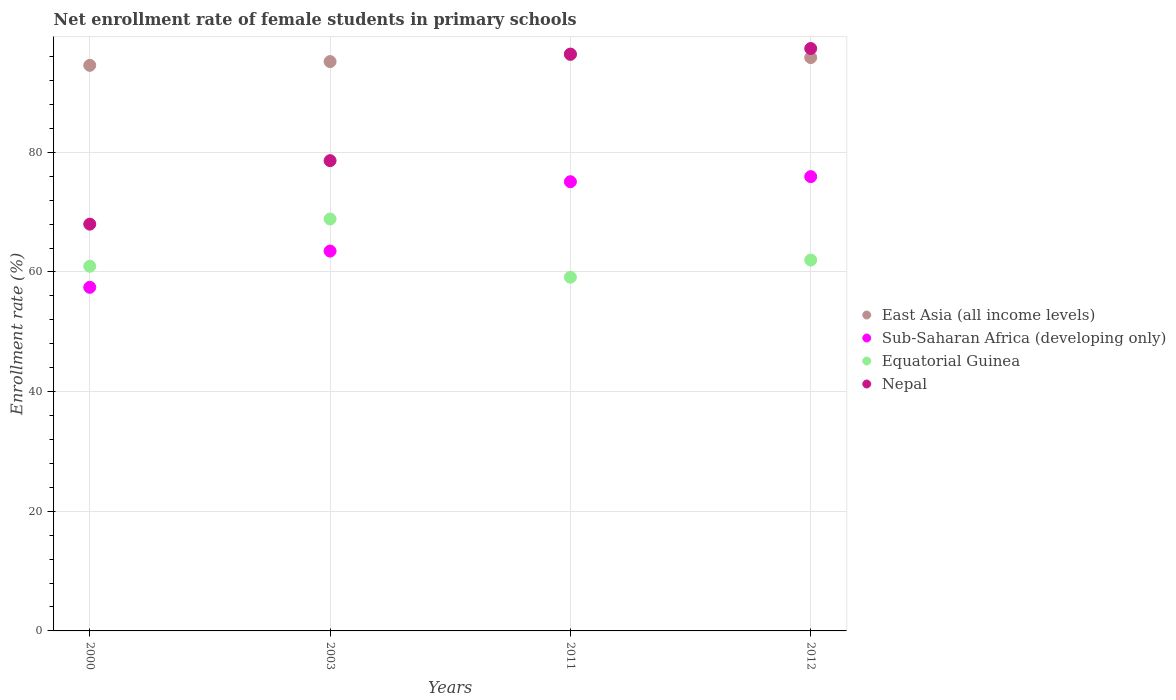Is the number of dotlines equal to the number of legend labels?
Keep it short and to the point. Yes. What is the net enrollment rate of female students in primary schools in East Asia (all income levels) in 2012?
Ensure brevity in your answer.  95.83. Across all years, what is the maximum net enrollment rate of female students in primary schools in East Asia (all income levels)?
Your answer should be compact. 96.33. Across all years, what is the minimum net enrollment rate of female students in primary schools in Equatorial Guinea?
Offer a very short reply. 59.13. In which year was the net enrollment rate of female students in primary schools in Sub-Saharan Africa (developing only) maximum?
Ensure brevity in your answer.  2012. What is the total net enrollment rate of female students in primary schools in East Asia (all income levels) in the graph?
Make the answer very short. 381.87. What is the difference between the net enrollment rate of female students in primary schools in East Asia (all income levels) in 2011 and that in 2012?
Offer a terse response. 0.49. What is the difference between the net enrollment rate of female students in primary schools in Sub-Saharan Africa (developing only) in 2011 and the net enrollment rate of female students in primary schools in Equatorial Guinea in 2000?
Offer a very short reply. 14.13. What is the average net enrollment rate of female students in primary schools in East Asia (all income levels) per year?
Give a very brief answer. 95.47. In the year 2012, what is the difference between the net enrollment rate of female students in primary schools in Equatorial Guinea and net enrollment rate of female students in primary schools in Sub-Saharan Africa (developing only)?
Give a very brief answer. -13.95. What is the ratio of the net enrollment rate of female students in primary schools in East Asia (all income levels) in 2000 to that in 2003?
Keep it short and to the point. 0.99. Is the net enrollment rate of female students in primary schools in Equatorial Guinea in 2003 less than that in 2012?
Keep it short and to the point. No. Is the difference between the net enrollment rate of female students in primary schools in Equatorial Guinea in 2000 and 2003 greater than the difference between the net enrollment rate of female students in primary schools in Sub-Saharan Africa (developing only) in 2000 and 2003?
Ensure brevity in your answer.  No. What is the difference between the highest and the second highest net enrollment rate of female students in primary schools in Equatorial Guinea?
Provide a short and direct response. 6.86. What is the difference between the highest and the lowest net enrollment rate of female students in primary schools in East Asia (all income levels)?
Ensure brevity in your answer.  1.79. Is the sum of the net enrollment rate of female students in primary schools in Equatorial Guinea in 2011 and 2012 greater than the maximum net enrollment rate of female students in primary schools in Sub-Saharan Africa (developing only) across all years?
Offer a very short reply. Yes. Is the net enrollment rate of female students in primary schools in Nepal strictly less than the net enrollment rate of female students in primary schools in East Asia (all income levels) over the years?
Keep it short and to the point. No. How many years are there in the graph?
Provide a short and direct response. 4. How many legend labels are there?
Your response must be concise. 4. What is the title of the graph?
Make the answer very short. Net enrollment rate of female students in primary schools. What is the label or title of the Y-axis?
Your answer should be very brief. Enrollment rate (%). What is the Enrollment rate (%) of East Asia (all income levels) in 2000?
Ensure brevity in your answer.  94.54. What is the Enrollment rate (%) of Sub-Saharan Africa (developing only) in 2000?
Make the answer very short. 57.43. What is the Enrollment rate (%) in Equatorial Guinea in 2000?
Your answer should be very brief. 60.96. What is the Enrollment rate (%) in Nepal in 2000?
Give a very brief answer. 67.99. What is the Enrollment rate (%) of East Asia (all income levels) in 2003?
Provide a short and direct response. 95.17. What is the Enrollment rate (%) in Sub-Saharan Africa (developing only) in 2003?
Make the answer very short. 63.49. What is the Enrollment rate (%) of Equatorial Guinea in 2003?
Give a very brief answer. 68.85. What is the Enrollment rate (%) in Nepal in 2003?
Provide a succinct answer. 78.61. What is the Enrollment rate (%) of East Asia (all income levels) in 2011?
Your response must be concise. 96.33. What is the Enrollment rate (%) of Sub-Saharan Africa (developing only) in 2011?
Your answer should be compact. 75.09. What is the Enrollment rate (%) of Equatorial Guinea in 2011?
Offer a very short reply. 59.13. What is the Enrollment rate (%) in Nepal in 2011?
Your answer should be very brief. 96.42. What is the Enrollment rate (%) in East Asia (all income levels) in 2012?
Offer a very short reply. 95.83. What is the Enrollment rate (%) in Sub-Saharan Africa (developing only) in 2012?
Make the answer very short. 75.94. What is the Enrollment rate (%) in Equatorial Guinea in 2012?
Offer a very short reply. 61.99. What is the Enrollment rate (%) of Nepal in 2012?
Make the answer very short. 97.35. Across all years, what is the maximum Enrollment rate (%) in East Asia (all income levels)?
Offer a terse response. 96.33. Across all years, what is the maximum Enrollment rate (%) of Sub-Saharan Africa (developing only)?
Offer a very short reply. 75.94. Across all years, what is the maximum Enrollment rate (%) of Equatorial Guinea?
Offer a very short reply. 68.85. Across all years, what is the maximum Enrollment rate (%) of Nepal?
Offer a terse response. 97.35. Across all years, what is the minimum Enrollment rate (%) of East Asia (all income levels)?
Ensure brevity in your answer.  94.54. Across all years, what is the minimum Enrollment rate (%) in Sub-Saharan Africa (developing only)?
Ensure brevity in your answer.  57.43. Across all years, what is the minimum Enrollment rate (%) in Equatorial Guinea?
Provide a short and direct response. 59.13. Across all years, what is the minimum Enrollment rate (%) of Nepal?
Your answer should be very brief. 67.99. What is the total Enrollment rate (%) in East Asia (all income levels) in the graph?
Provide a succinct answer. 381.87. What is the total Enrollment rate (%) in Sub-Saharan Africa (developing only) in the graph?
Keep it short and to the point. 271.95. What is the total Enrollment rate (%) of Equatorial Guinea in the graph?
Make the answer very short. 250.93. What is the total Enrollment rate (%) in Nepal in the graph?
Provide a short and direct response. 340.37. What is the difference between the Enrollment rate (%) in East Asia (all income levels) in 2000 and that in 2003?
Your answer should be very brief. -0.63. What is the difference between the Enrollment rate (%) of Sub-Saharan Africa (developing only) in 2000 and that in 2003?
Ensure brevity in your answer.  -6.06. What is the difference between the Enrollment rate (%) of Equatorial Guinea in 2000 and that in 2003?
Your answer should be compact. -7.9. What is the difference between the Enrollment rate (%) in Nepal in 2000 and that in 2003?
Offer a terse response. -10.61. What is the difference between the Enrollment rate (%) in East Asia (all income levels) in 2000 and that in 2011?
Make the answer very short. -1.79. What is the difference between the Enrollment rate (%) in Sub-Saharan Africa (developing only) in 2000 and that in 2011?
Provide a succinct answer. -17.65. What is the difference between the Enrollment rate (%) in Equatorial Guinea in 2000 and that in 2011?
Offer a very short reply. 1.83. What is the difference between the Enrollment rate (%) of Nepal in 2000 and that in 2011?
Keep it short and to the point. -28.43. What is the difference between the Enrollment rate (%) of East Asia (all income levels) in 2000 and that in 2012?
Your response must be concise. -1.29. What is the difference between the Enrollment rate (%) in Sub-Saharan Africa (developing only) in 2000 and that in 2012?
Provide a succinct answer. -18.5. What is the difference between the Enrollment rate (%) in Equatorial Guinea in 2000 and that in 2012?
Provide a short and direct response. -1.04. What is the difference between the Enrollment rate (%) of Nepal in 2000 and that in 2012?
Make the answer very short. -29.36. What is the difference between the Enrollment rate (%) of East Asia (all income levels) in 2003 and that in 2011?
Your answer should be very brief. -1.16. What is the difference between the Enrollment rate (%) of Sub-Saharan Africa (developing only) in 2003 and that in 2011?
Your response must be concise. -11.6. What is the difference between the Enrollment rate (%) in Equatorial Guinea in 2003 and that in 2011?
Provide a succinct answer. 9.73. What is the difference between the Enrollment rate (%) of Nepal in 2003 and that in 2011?
Give a very brief answer. -17.81. What is the difference between the Enrollment rate (%) in East Asia (all income levels) in 2003 and that in 2012?
Ensure brevity in your answer.  -0.67. What is the difference between the Enrollment rate (%) of Sub-Saharan Africa (developing only) in 2003 and that in 2012?
Provide a short and direct response. -12.45. What is the difference between the Enrollment rate (%) of Equatorial Guinea in 2003 and that in 2012?
Offer a very short reply. 6.86. What is the difference between the Enrollment rate (%) of Nepal in 2003 and that in 2012?
Keep it short and to the point. -18.74. What is the difference between the Enrollment rate (%) of East Asia (all income levels) in 2011 and that in 2012?
Offer a very short reply. 0.49. What is the difference between the Enrollment rate (%) in Sub-Saharan Africa (developing only) in 2011 and that in 2012?
Your answer should be compact. -0.85. What is the difference between the Enrollment rate (%) in Equatorial Guinea in 2011 and that in 2012?
Your response must be concise. -2.87. What is the difference between the Enrollment rate (%) of Nepal in 2011 and that in 2012?
Ensure brevity in your answer.  -0.93. What is the difference between the Enrollment rate (%) of East Asia (all income levels) in 2000 and the Enrollment rate (%) of Sub-Saharan Africa (developing only) in 2003?
Give a very brief answer. 31.05. What is the difference between the Enrollment rate (%) in East Asia (all income levels) in 2000 and the Enrollment rate (%) in Equatorial Guinea in 2003?
Your answer should be compact. 25.69. What is the difference between the Enrollment rate (%) in East Asia (all income levels) in 2000 and the Enrollment rate (%) in Nepal in 2003?
Provide a succinct answer. 15.93. What is the difference between the Enrollment rate (%) of Sub-Saharan Africa (developing only) in 2000 and the Enrollment rate (%) of Equatorial Guinea in 2003?
Make the answer very short. -11.42. What is the difference between the Enrollment rate (%) in Sub-Saharan Africa (developing only) in 2000 and the Enrollment rate (%) in Nepal in 2003?
Provide a succinct answer. -21.17. What is the difference between the Enrollment rate (%) in Equatorial Guinea in 2000 and the Enrollment rate (%) in Nepal in 2003?
Ensure brevity in your answer.  -17.65. What is the difference between the Enrollment rate (%) of East Asia (all income levels) in 2000 and the Enrollment rate (%) of Sub-Saharan Africa (developing only) in 2011?
Your response must be concise. 19.45. What is the difference between the Enrollment rate (%) of East Asia (all income levels) in 2000 and the Enrollment rate (%) of Equatorial Guinea in 2011?
Your response must be concise. 35.41. What is the difference between the Enrollment rate (%) of East Asia (all income levels) in 2000 and the Enrollment rate (%) of Nepal in 2011?
Your answer should be very brief. -1.88. What is the difference between the Enrollment rate (%) of Sub-Saharan Africa (developing only) in 2000 and the Enrollment rate (%) of Equatorial Guinea in 2011?
Offer a terse response. -1.69. What is the difference between the Enrollment rate (%) in Sub-Saharan Africa (developing only) in 2000 and the Enrollment rate (%) in Nepal in 2011?
Keep it short and to the point. -38.99. What is the difference between the Enrollment rate (%) in Equatorial Guinea in 2000 and the Enrollment rate (%) in Nepal in 2011?
Ensure brevity in your answer.  -35.46. What is the difference between the Enrollment rate (%) of East Asia (all income levels) in 2000 and the Enrollment rate (%) of Sub-Saharan Africa (developing only) in 2012?
Provide a short and direct response. 18.6. What is the difference between the Enrollment rate (%) of East Asia (all income levels) in 2000 and the Enrollment rate (%) of Equatorial Guinea in 2012?
Offer a very short reply. 32.55. What is the difference between the Enrollment rate (%) in East Asia (all income levels) in 2000 and the Enrollment rate (%) in Nepal in 2012?
Make the answer very short. -2.81. What is the difference between the Enrollment rate (%) of Sub-Saharan Africa (developing only) in 2000 and the Enrollment rate (%) of Equatorial Guinea in 2012?
Give a very brief answer. -4.56. What is the difference between the Enrollment rate (%) in Sub-Saharan Africa (developing only) in 2000 and the Enrollment rate (%) in Nepal in 2012?
Your answer should be compact. -39.92. What is the difference between the Enrollment rate (%) of Equatorial Guinea in 2000 and the Enrollment rate (%) of Nepal in 2012?
Keep it short and to the point. -36.39. What is the difference between the Enrollment rate (%) of East Asia (all income levels) in 2003 and the Enrollment rate (%) of Sub-Saharan Africa (developing only) in 2011?
Your response must be concise. 20.08. What is the difference between the Enrollment rate (%) in East Asia (all income levels) in 2003 and the Enrollment rate (%) in Equatorial Guinea in 2011?
Ensure brevity in your answer.  36.04. What is the difference between the Enrollment rate (%) in East Asia (all income levels) in 2003 and the Enrollment rate (%) in Nepal in 2011?
Your response must be concise. -1.25. What is the difference between the Enrollment rate (%) of Sub-Saharan Africa (developing only) in 2003 and the Enrollment rate (%) of Equatorial Guinea in 2011?
Ensure brevity in your answer.  4.36. What is the difference between the Enrollment rate (%) in Sub-Saharan Africa (developing only) in 2003 and the Enrollment rate (%) in Nepal in 2011?
Offer a terse response. -32.93. What is the difference between the Enrollment rate (%) of Equatorial Guinea in 2003 and the Enrollment rate (%) of Nepal in 2011?
Provide a short and direct response. -27.57. What is the difference between the Enrollment rate (%) in East Asia (all income levels) in 2003 and the Enrollment rate (%) in Sub-Saharan Africa (developing only) in 2012?
Ensure brevity in your answer.  19.23. What is the difference between the Enrollment rate (%) of East Asia (all income levels) in 2003 and the Enrollment rate (%) of Equatorial Guinea in 2012?
Offer a very short reply. 33.17. What is the difference between the Enrollment rate (%) in East Asia (all income levels) in 2003 and the Enrollment rate (%) in Nepal in 2012?
Offer a very short reply. -2.18. What is the difference between the Enrollment rate (%) in Sub-Saharan Africa (developing only) in 2003 and the Enrollment rate (%) in Equatorial Guinea in 2012?
Your answer should be compact. 1.5. What is the difference between the Enrollment rate (%) of Sub-Saharan Africa (developing only) in 2003 and the Enrollment rate (%) of Nepal in 2012?
Ensure brevity in your answer.  -33.86. What is the difference between the Enrollment rate (%) of Equatorial Guinea in 2003 and the Enrollment rate (%) of Nepal in 2012?
Keep it short and to the point. -28.5. What is the difference between the Enrollment rate (%) in East Asia (all income levels) in 2011 and the Enrollment rate (%) in Sub-Saharan Africa (developing only) in 2012?
Offer a terse response. 20.39. What is the difference between the Enrollment rate (%) in East Asia (all income levels) in 2011 and the Enrollment rate (%) in Equatorial Guinea in 2012?
Provide a succinct answer. 34.34. What is the difference between the Enrollment rate (%) in East Asia (all income levels) in 2011 and the Enrollment rate (%) in Nepal in 2012?
Your answer should be very brief. -1.02. What is the difference between the Enrollment rate (%) in Sub-Saharan Africa (developing only) in 2011 and the Enrollment rate (%) in Equatorial Guinea in 2012?
Provide a short and direct response. 13.1. What is the difference between the Enrollment rate (%) in Sub-Saharan Africa (developing only) in 2011 and the Enrollment rate (%) in Nepal in 2012?
Keep it short and to the point. -22.26. What is the difference between the Enrollment rate (%) in Equatorial Guinea in 2011 and the Enrollment rate (%) in Nepal in 2012?
Your response must be concise. -38.22. What is the average Enrollment rate (%) of East Asia (all income levels) per year?
Provide a short and direct response. 95.47. What is the average Enrollment rate (%) in Sub-Saharan Africa (developing only) per year?
Keep it short and to the point. 67.99. What is the average Enrollment rate (%) in Equatorial Guinea per year?
Offer a very short reply. 62.73. What is the average Enrollment rate (%) of Nepal per year?
Keep it short and to the point. 85.09. In the year 2000, what is the difference between the Enrollment rate (%) of East Asia (all income levels) and Enrollment rate (%) of Sub-Saharan Africa (developing only)?
Offer a terse response. 37.11. In the year 2000, what is the difference between the Enrollment rate (%) of East Asia (all income levels) and Enrollment rate (%) of Equatorial Guinea?
Keep it short and to the point. 33.58. In the year 2000, what is the difference between the Enrollment rate (%) of East Asia (all income levels) and Enrollment rate (%) of Nepal?
Your answer should be compact. 26.55. In the year 2000, what is the difference between the Enrollment rate (%) in Sub-Saharan Africa (developing only) and Enrollment rate (%) in Equatorial Guinea?
Your answer should be very brief. -3.52. In the year 2000, what is the difference between the Enrollment rate (%) of Sub-Saharan Africa (developing only) and Enrollment rate (%) of Nepal?
Keep it short and to the point. -10.56. In the year 2000, what is the difference between the Enrollment rate (%) of Equatorial Guinea and Enrollment rate (%) of Nepal?
Give a very brief answer. -7.04. In the year 2003, what is the difference between the Enrollment rate (%) in East Asia (all income levels) and Enrollment rate (%) in Sub-Saharan Africa (developing only)?
Ensure brevity in your answer.  31.68. In the year 2003, what is the difference between the Enrollment rate (%) in East Asia (all income levels) and Enrollment rate (%) in Equatorial Guinea?
Offer a very short reply. 26.31. In the year 2003, what is the difference between the Enrollment rate (%) in East Asia (all income levels) and Enrollment rate (%) in Nepal?
Keep it short and to the point. 16.56. In the year 2003, what is the difference between the Enrollment rate (%) of Sub-Saharan Africa (developing only) and Enrollment rate (%) of Equatorial Guinea?
Offer a terse response. -5.36. In the year 2003, what is the difference between the Enrollment rate (%) of Sub-Saharan Africa (developing only) and Enrollment rate (%) of Nepal?
Offer a very short reply. -15.12. In the year 2003, what is the difference between the Enrollment rate (%) in Equatorial Guinea and Enrollment rate (%) in Nepal?
Ensure brevity in your answer.  -9.75. In the year 2011, what is the difference between the Enrollment rate (%) of East Asia (all income levels) and Enrollment rate (%) of Sub-Saharan Africa (developing only)?
Offer a terse response. 21.24. In the year 2011, what is the difference between the Enrollment rate (%) in East Asia (all income levels) and Enrollment rate (%) in Equatorial Guinea?
Ensure brevity in your answer.  37.2. In the year 2011, what is the difference between the Enrollment rate (%) of East Asia (all income levels) and Enrollment rate (%) of Nepal?
Provide a short and direct response. -0.09. In the year 2011, what is the difference between the Enrollment rate (%) in Sub-Saharan Africa (developing only) and Enrollment rate (%) in Equatorial Guinea?
Ensure brevity in your answer.  15.96. In the year 2011, what is the difference between the Enrollment rate (%) in Sub-Saharan Africa (developing only) and Enrollment rate (%) in Nepal?
Provide a short and direct response. -21.33. In the year 2011, what is the difference between the Enrollment rate (%) in Equatorial Guinea and Enrollment rate (%) in Nepal?
Give a very brief answer. -37.29. In the year 2012, what is the difference between the Enrollment rate (%) in East Asia (all income levels) and Enrollment rate (%) in Sub-Saharan Africa (developing only)?
Your response must be concise. 19.9. In the year 2012, what is the difference between the Enrollment rate (%) of East Asia (all income levels) and Enrollment rate (%) of Equatorial Guinea?
Keep it short and to the point. 33.84. In the year 2012, what is the difference between the Enrollment rate (%) in East Asia (all income levels) and Enrollment rate (%) in Nepal?
Your answer should be very brief. -1.52. In the year 2012, what is the difference between the Enrollment rate (%) of Sub-Saharan Africa (developing only) and Enrollment rate (%) of Equatorial Guinea?
Offer a very short reply. 13.95. In the year 2012, what is the difference between the Enrollment rate (%) of Sub-Saharan Africa (developing only) and Enrollment rate (%) of Nepal?
Offer a terse response. -21.41. In the year 2012, what is the difference between the Enrollment rate (%) in Equatorial Guinea and Enrollment rate (%) in Nepal?
Provide a short and direct response. -35.36. What is the ratio of the Enrollment rate (%) of East Asia (all income levels) in 2000 to that in 2003?
Provide a succinct answer. 0.99. What is the ratio of the Enrollment rate (%) of Sub-Saharan Africa (developing only) in 2000 to that in 2003?
Offer a terse response. 0.9. What is the ratio of the Enrollment rate (%) of Equatorial Guinea in 2000 to that in 2003?
Your response must be concise. 0.89. What is the ratio of the Enrollment rate (%) in Nepal in 2000 to that in 2003?
Your answer should be compact. 0.86. What is the ratio of the Enrollment rate (%) in East Asia (all income levels) in 2000 to that in 2011?
Provide a short and direct response. 0.98. What is the ratio of the Enrollment rate (%) in Sub-Saharan Africa (developing only) in 2000 to that in 2011?
Provide a succinct answer. 0.76. What is the ratio of the Enrollment rate (%) of Equatorial Guinea in 2000 to that in 2011?
Offer a terse response. 1.03. What is the ratio of the Enrollment rate (%) in Nepal in 2000 to that in 2011?
Your answer should be compact. 0.71. What is the ratio of the Enrollment rate (%) of East Asia (all income levels) in 2000 to that in 2012?
Give a very brief answer. 0.99. What is the ratio of the Enrollment rate (%) in Sub-Saharan Africa (developing only) in 2000 to that in 2012?
Provide a short and direct response. 0.76. What is the ratio of the Enrollment rate (%) of Equatorial Guinea in 2000 to that in 2012?
Your response must be concise. 0.98. What is the ratio of the Enrollment rate (%) of Nepal in 2000 to that in 2012?
Make the answer very short. 0.7. What is the ratio of the Enrollment rate (%) of East Asia (all income levels) in 2003 to that in 2011?
Offer a very short reply. 0.99. What is the ratio of the Enrollment rate (%) in Sub-Saharan Africa (developing only) in 2003 to that in 2011?
Offer a terse response. 0.85. What is the ratio of the Enrollment rate (%) in Equatorial Guinea in 2003 to that in 2011?
Make the answer very short. 1.16. What is the ratio of the Enrollment rate (%) of Nepal in 2003 to that in 2011?
Ensure brevity in your answer.  0.82. What is the ratio of the Enrollment rate (%) in Sub-Saharan Africa (developing only) in 2003 to that in 2012?
Offer a terse response. 0.84. What is the ratio of the Enrollment rate (%) in Equatorial Guinea in 2003 to that in 2012?
Provide a succinct answer. 1.11. What is the ratio of the Enrollment rate (%) of Nepal in 2003 to that in 2012?
Ensure brevity in your answer.  0.81. What is the ratio of the Enrollment rate (%) in Equatorial Guinea in 2011 to that in 2012?
Offer a terse response. 0.95. What is the difference between the highest and the second highest Enrollment rate (%) of East Asia (all income levels)?
Your answer should be compact. 0.49. What is the difference between the highest and the second highest Enrollment rate (%) in Sub-Saharan Africa (developing only)?
Offer a terse response. 0.85. What is the difference between the highest and the second highest Enrollment rate (%) of Equatorial Guinea?
Your answer should be very brief. 6.86. What is the difference between the highest and the second highest Enrollment rate (%) in Nepal?
Offer a terse response. 0.93. What is the difference between the highest and the lowest Enrollment rate (%) of East Asia (all income levels)?
Offer a very short reply. 1.79. What is the difference between the highest and the lowest Enrollment rate (%) of Sub-Saharan Africa (developing only)?
Keep it short and to the point. 18.5. What is the difference between the highest and the lowest Enrollment rate (%) in Equatorial Guinea?
Make the answer very short. 9.73. What is the difference between the highest and the lowest Enrollment rate (%) in Nepal?
Make the answer very short. 29.36. 